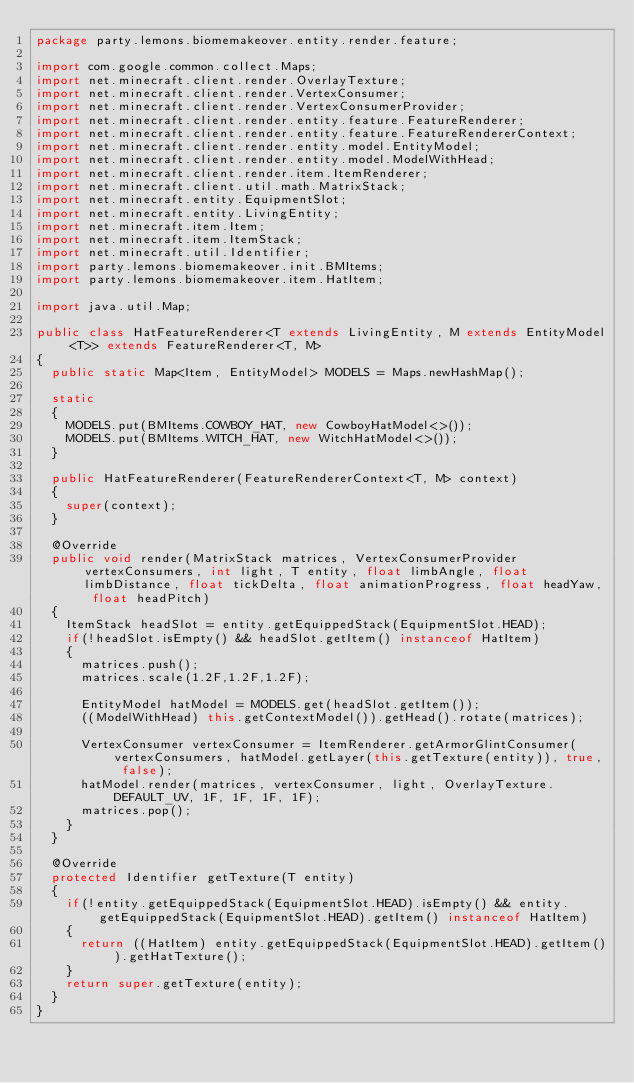<code> <loc_0><loc_0><loc_500><loc_500><_Java_>package party.lemons.biomemakeover.entity.render.feature;

import com.google.common.collect.Maps;
import net.minecraft.client.render.OverlayTexture;
import net.minecraft.client.render.VertexConsumer;
import net.minecraft.client.render.VertexConsumerProvider;
import net.minecraft.client.render.entity.feature.FeatureRenderer;
import net.minecraft.client.render.entity.feature.FeatureRendererContext;
import net.minecraft.client.render.entity.model.EntityModel;
import net.minecraft.client.render.entity.model.ModelWithHead;
import net.minecraft.client.render.item.ItemRenderer;
import net.minecraft.client.util.math.MatrixStack;
import net.minecraft.entity.EquipmentSlot;
import net.minecraft.entity.LivingEntity;
import net.minecraft.item.Item;
import net.minecraft.item.ItemStack;
import net.minecraft.util.Identifier;
import party.lemons.biomemakeover.init.BMItems;
import party.lemons.biomemakeover.item.HatItem;

import java.util.Map;

public class HatFeatureRenderer<T extends LivingEntity, M extends EntityModel<T>> extends FeatureRenderer<T, M>
{
	public static Map<Item, EntityModel> MODELS = Maps.newHashMap();

	static
	{
		MODELS.put(BMItems.COWBOY_HAT, new CowboyHatModel<>());
		MODELS.put(BMItems.WITCH_HAT, new WitchHatModel<>());
	}

	public HatFeatureRenderer(FeatureRendererContext<T, M> context)
	{
		super(context);
	}

	@Override
	public void render(MatrixStack matrices, VertexConsumerProvider vertexConsumers, int light, T entity, float limbAngle, float limbDistance, float tickDelta, float animationProgress, float headYaw, float headPitch)
	{
		ItemStack headSlot = entity.getEquippedStack(EquipmentSlot.HEAD);
		if(!headSlot.isEmpty() && headSlot.getItem() instanceof HatItem)
		{
			matrices.push();
			matrices.scale(1.2F,1.2F,1.2F);

			EntityModel hatModel = MODELS.get(headSlot.getItem());
			((ModelWithHead) this.getContextModel()).getHead().rotate(matrices);

			VertexConsumer vertexConsumer = ItemRenderer.getArmorGlintConsumer(vertexConsumers, hatModel.getLayer(this.getTexture(entity)), true, false);
			hatModel.render(matrices, vertexConsumer, light, OverlayTexture.DEFAULT_UV, 1F, 1F, 1F, 1F);
			matrices.pop();
		}
	}

	@Override
	protected Identifier getTexture(T entity)
	{
		if(!entity.getEquippedStack(EquipmentSlot.HEAD).isEmpty() && entity.getEquippedStack(EquipmentSlot.HEAD).getItem() instanceof HatItem)
		{
			return ((HatItem) entity.getEquippedStack(EquipmentSlot.HEAD).getItem()).getHatTexture();
		}
		return super.getTexture(entity);
	}
}
</code> 